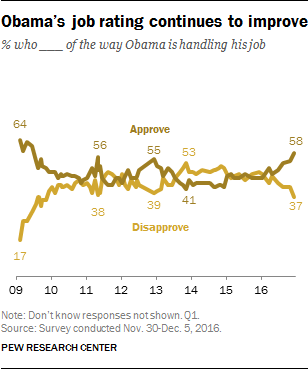Specify some key components in this picture. The difference between light and dark brown graphs is no more than 12 units. The rightmost value of the light brown graph is not 58. Instead, it is not. 